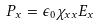<formula> <loc_0><loc_0><loc_500><loc_500>P _ { x } = \epsilon _ { 0 } \chi _ { x x } E _ { x }</formula> 